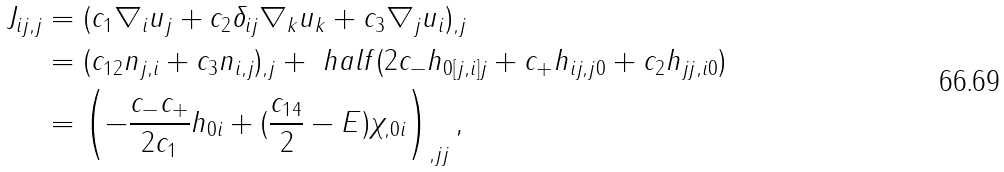<formula> <loc_0><loc_0><loc_500><loc_500>J _ { i j , j } & = ( c _ { 1 } \nabla _ { i } u _ { j } + c _ { 2 } \delta _ { i j } \nabla _ { k } u _ { k } + c _ { 3 } \nabla _ { j } u _ { i } ) _ { , j } \\ & = ( c _ { 1 2 } n _ { j , i } + c _ { 3 } n _ { i , j } ) _ { , j } + \ h a l f ( 2 c _ { - } h _ { 0 [ j , i ] j } + c _ { + } h _ { i j , j 0 } + c _ { 2 } h _ { j j , i 0 } ) \\ & = \left ( - \frac { c _ { - } c _ { + } } { 2 c _ { 1 } } h _ { 0 i } + ( \frac { c _ { 1 4 } } { 2 } - E ) \chi _ { , 0 i } \right ) _ { , j j } ,</formula> 